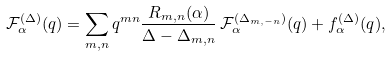Convert formula to latex. <formula><loc_0><loc_0><loc_500><loc_500>\mathcal { F } _ { \alpha } ^ { ( \Delta ) } ( q ) = \sum _ { m , n } q ^ { m n } \frac { R _ { m , n } ( \alpha ) } { \Delta - \Delta _ { m , n } } \, \mathcal { F } _ { \alpha } ^ { ( \Delta _ { m , - n } ) } ( q ) + f _ { \alpha } ^ { ( \Delta ) } ( q ) ,</formula> 